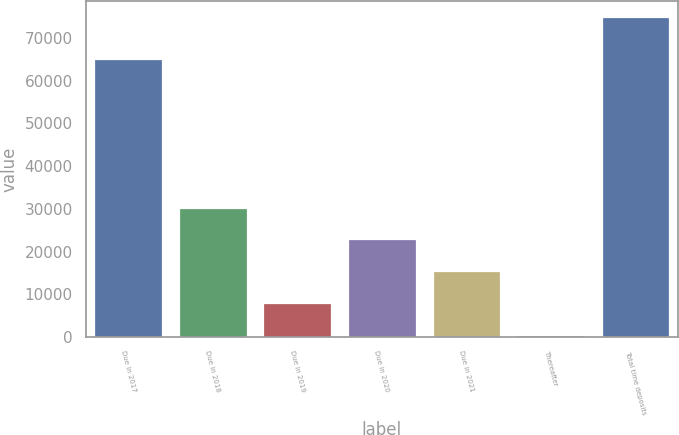Convert chart to OTSL. <chart><loc_0><loc_0><loc_500><loc_500><bar_chart><fcel>Due in 2017<fcel>Due in 2018<fcel>Due in 2019<fcel>Due in 2020<fcel>Due in 2021<fcel>Thereafter<fcel>Total time deposits<nl><fcel>65112<fcel>30278.8<fcel>7946.2<fcel>22834.6<fcel>15390.4<fcel>502<fcel>74944<nl></chart> 